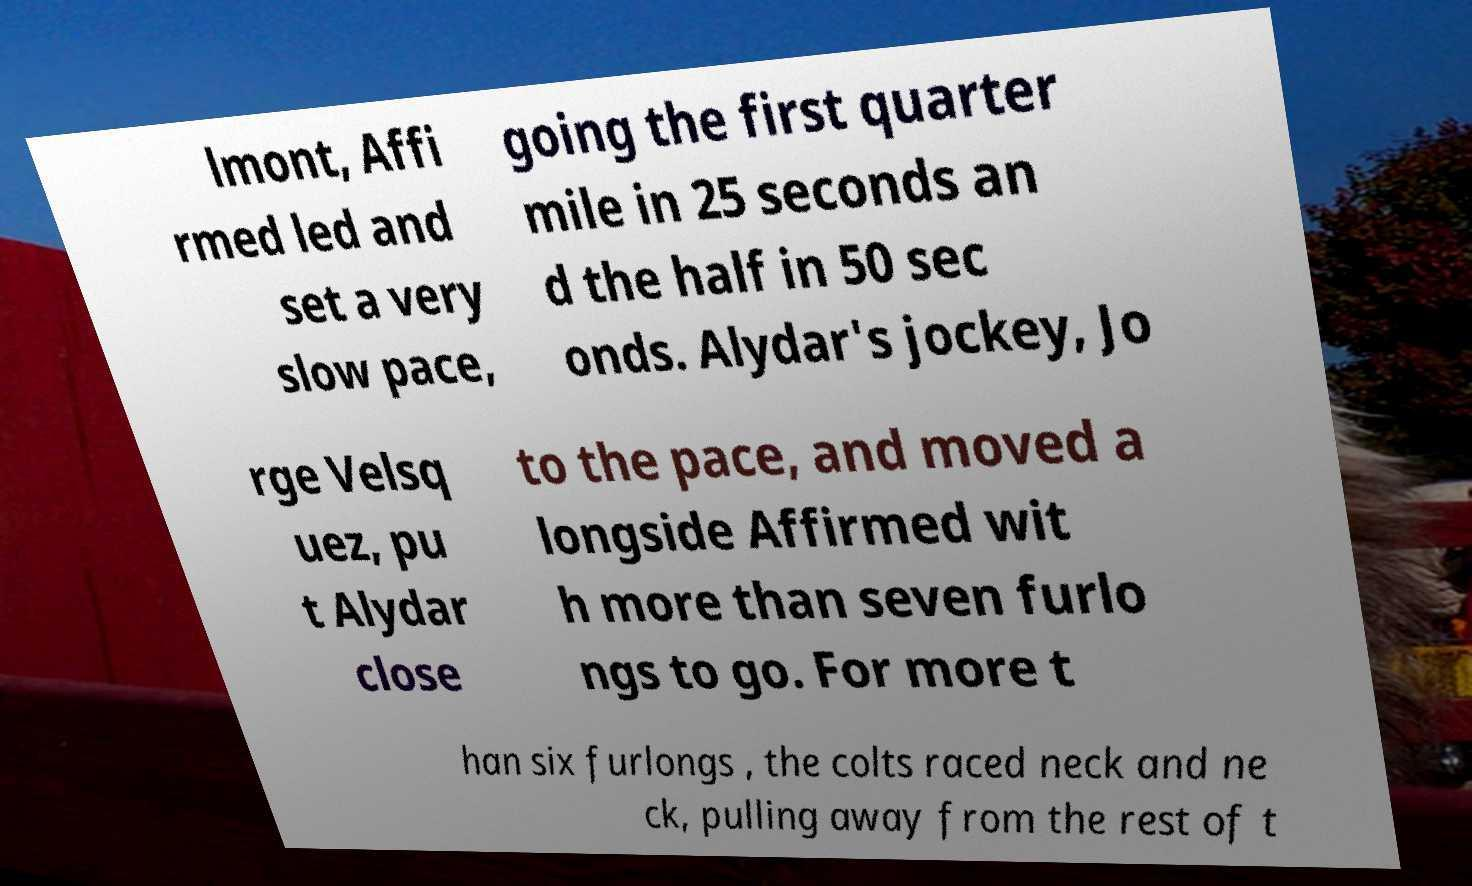Can you accurately transcribe the text from the provided image for me? lmont, Affi rmed led and set a very slow pace, going the first quarter mile in 25 seconds an d the half in 50 sec onds. Alydar's jockey, Jo rge Velsq uez, pu t Alydar close to the pace, and moved a longside Affirmed wit h more than seven furlo ngs to go. For more t han six furlongs , the colts raced neck and ne ck, pulling away from the rest of t 